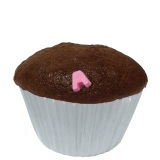Can you describe this item in more detail? Certainly! This item is a delicious-looking cupcake, probably made of chocolate, with a slightly domed top. It appears to have a small pink decoration, possibly made of fondant or candy.  What could be some creative toppings for this cupcake? You could top this cupcake with a variety of creative toppings such as a swirl of buttercream frosting, a drizzle of caramel or chocolate sauce, some colorful sprinkles, or even edible glitter. Fresh fruits like strawberries or raspberries would add a touch of elegance, while chopped nuts would add a nice crunch. Another fun option could be to add a small edible flower for a beautiful and natural decoration. 